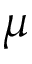<formula> <loc_0><loc_0><loc_500><loc_500>\mu</formula> 